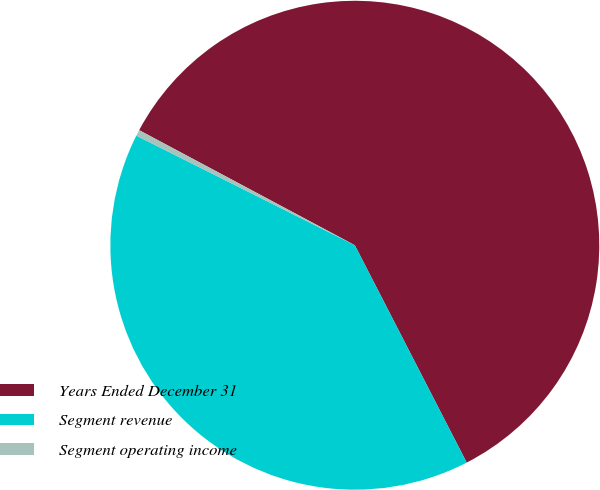Convert chart to OTSL. <chart><loc_0><loc_0><loc_500><loc_500><pie_chart><fcel>Years Ended December 31<fcel>Segment revenue<fcel>Segment operating income<nl><fcel>59.64%<fcel>39.97%<fcel>0.4%<nl></chart> 